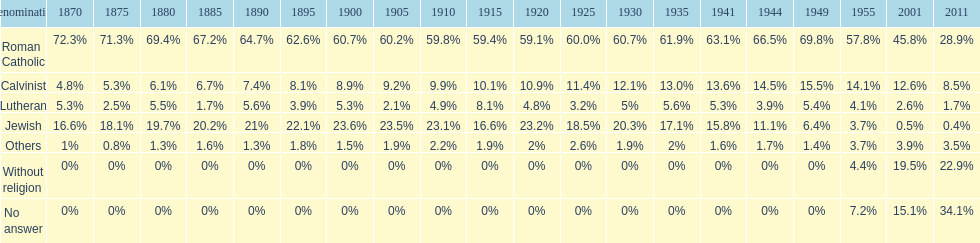The percentage of people who identified as calvinist was, at most, how much? 15.5%. 